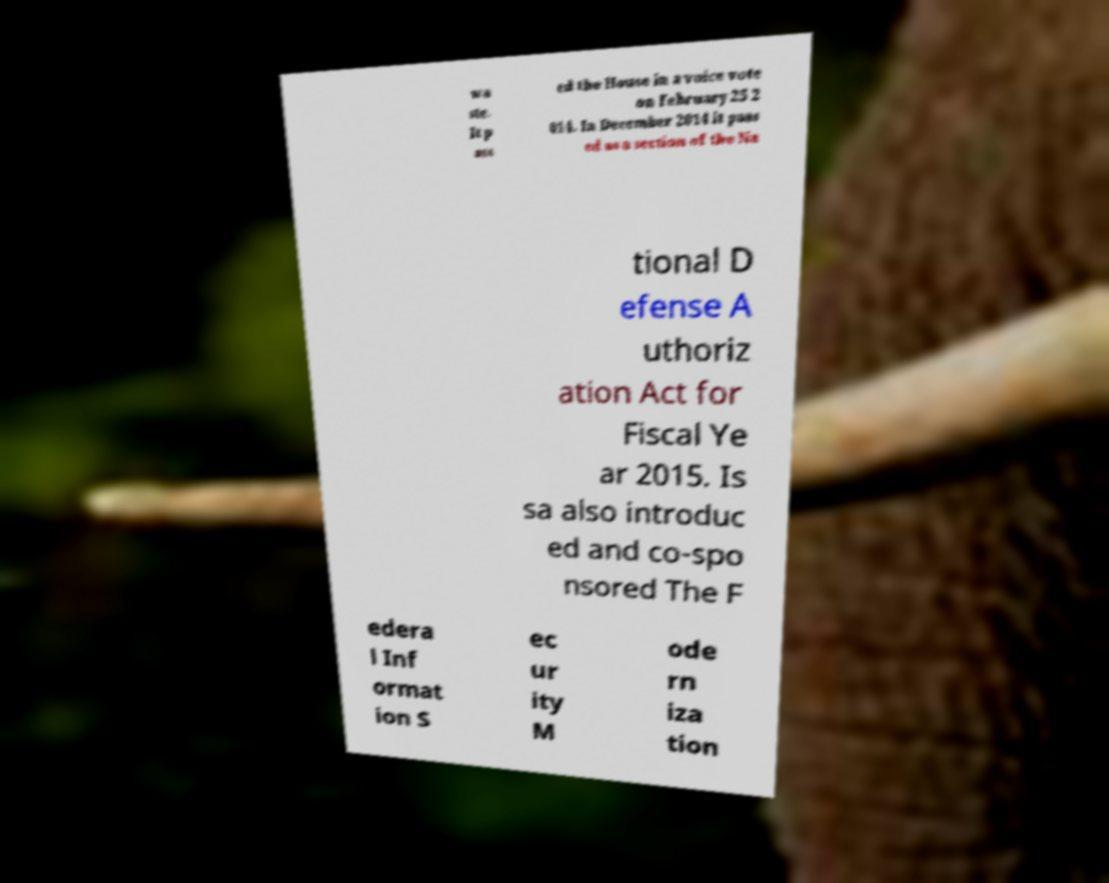Can you accurately transcribe the text from the provided image for me? wa ste. It p ass ed the House in a voice vote on February 25 2 014. In December 2014 it pass ed as a section of the Na tional D efense A uthoriz ation Act for Fiscal Ye ar 2015. Is sa also introduc ed and co-spo nsored The F edera l Inf ormat ion S ec ur ity M ode rn iza tion 